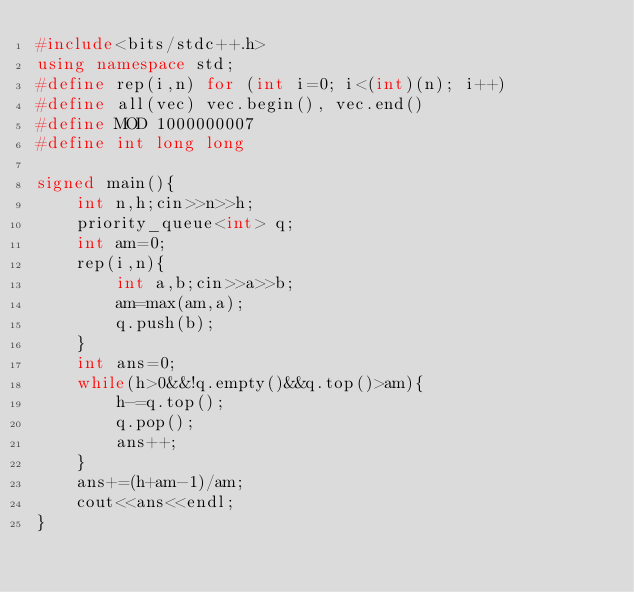<code> <loc_0><loc_0><loc_500><loc_500><_C++_>#include<bits/stdc++.h>
using namespace std;
#define rep(i,n) for (int i=0; i<(int)(n); i++)
#define all(vec) vec.begin(), vec.end()
#define MOD 1000000007
#define int long long

signed main(){
    int n,h;cin>>n>>h;
    priority_queue<int> q;
    int am=0;
    rep(i,n){
        int a,b;cin>>a>>b;
        am=max(am,a);
        q.push(b);
    }
    int ans=0;
    while(h>0&&!q.empty()&&q.top()>am){
        h-=q.top();
        q.pop();
        ans++;
    }
    ans+=(h+am-1)/am;
    cout<<ans<<endl;
}</code> 